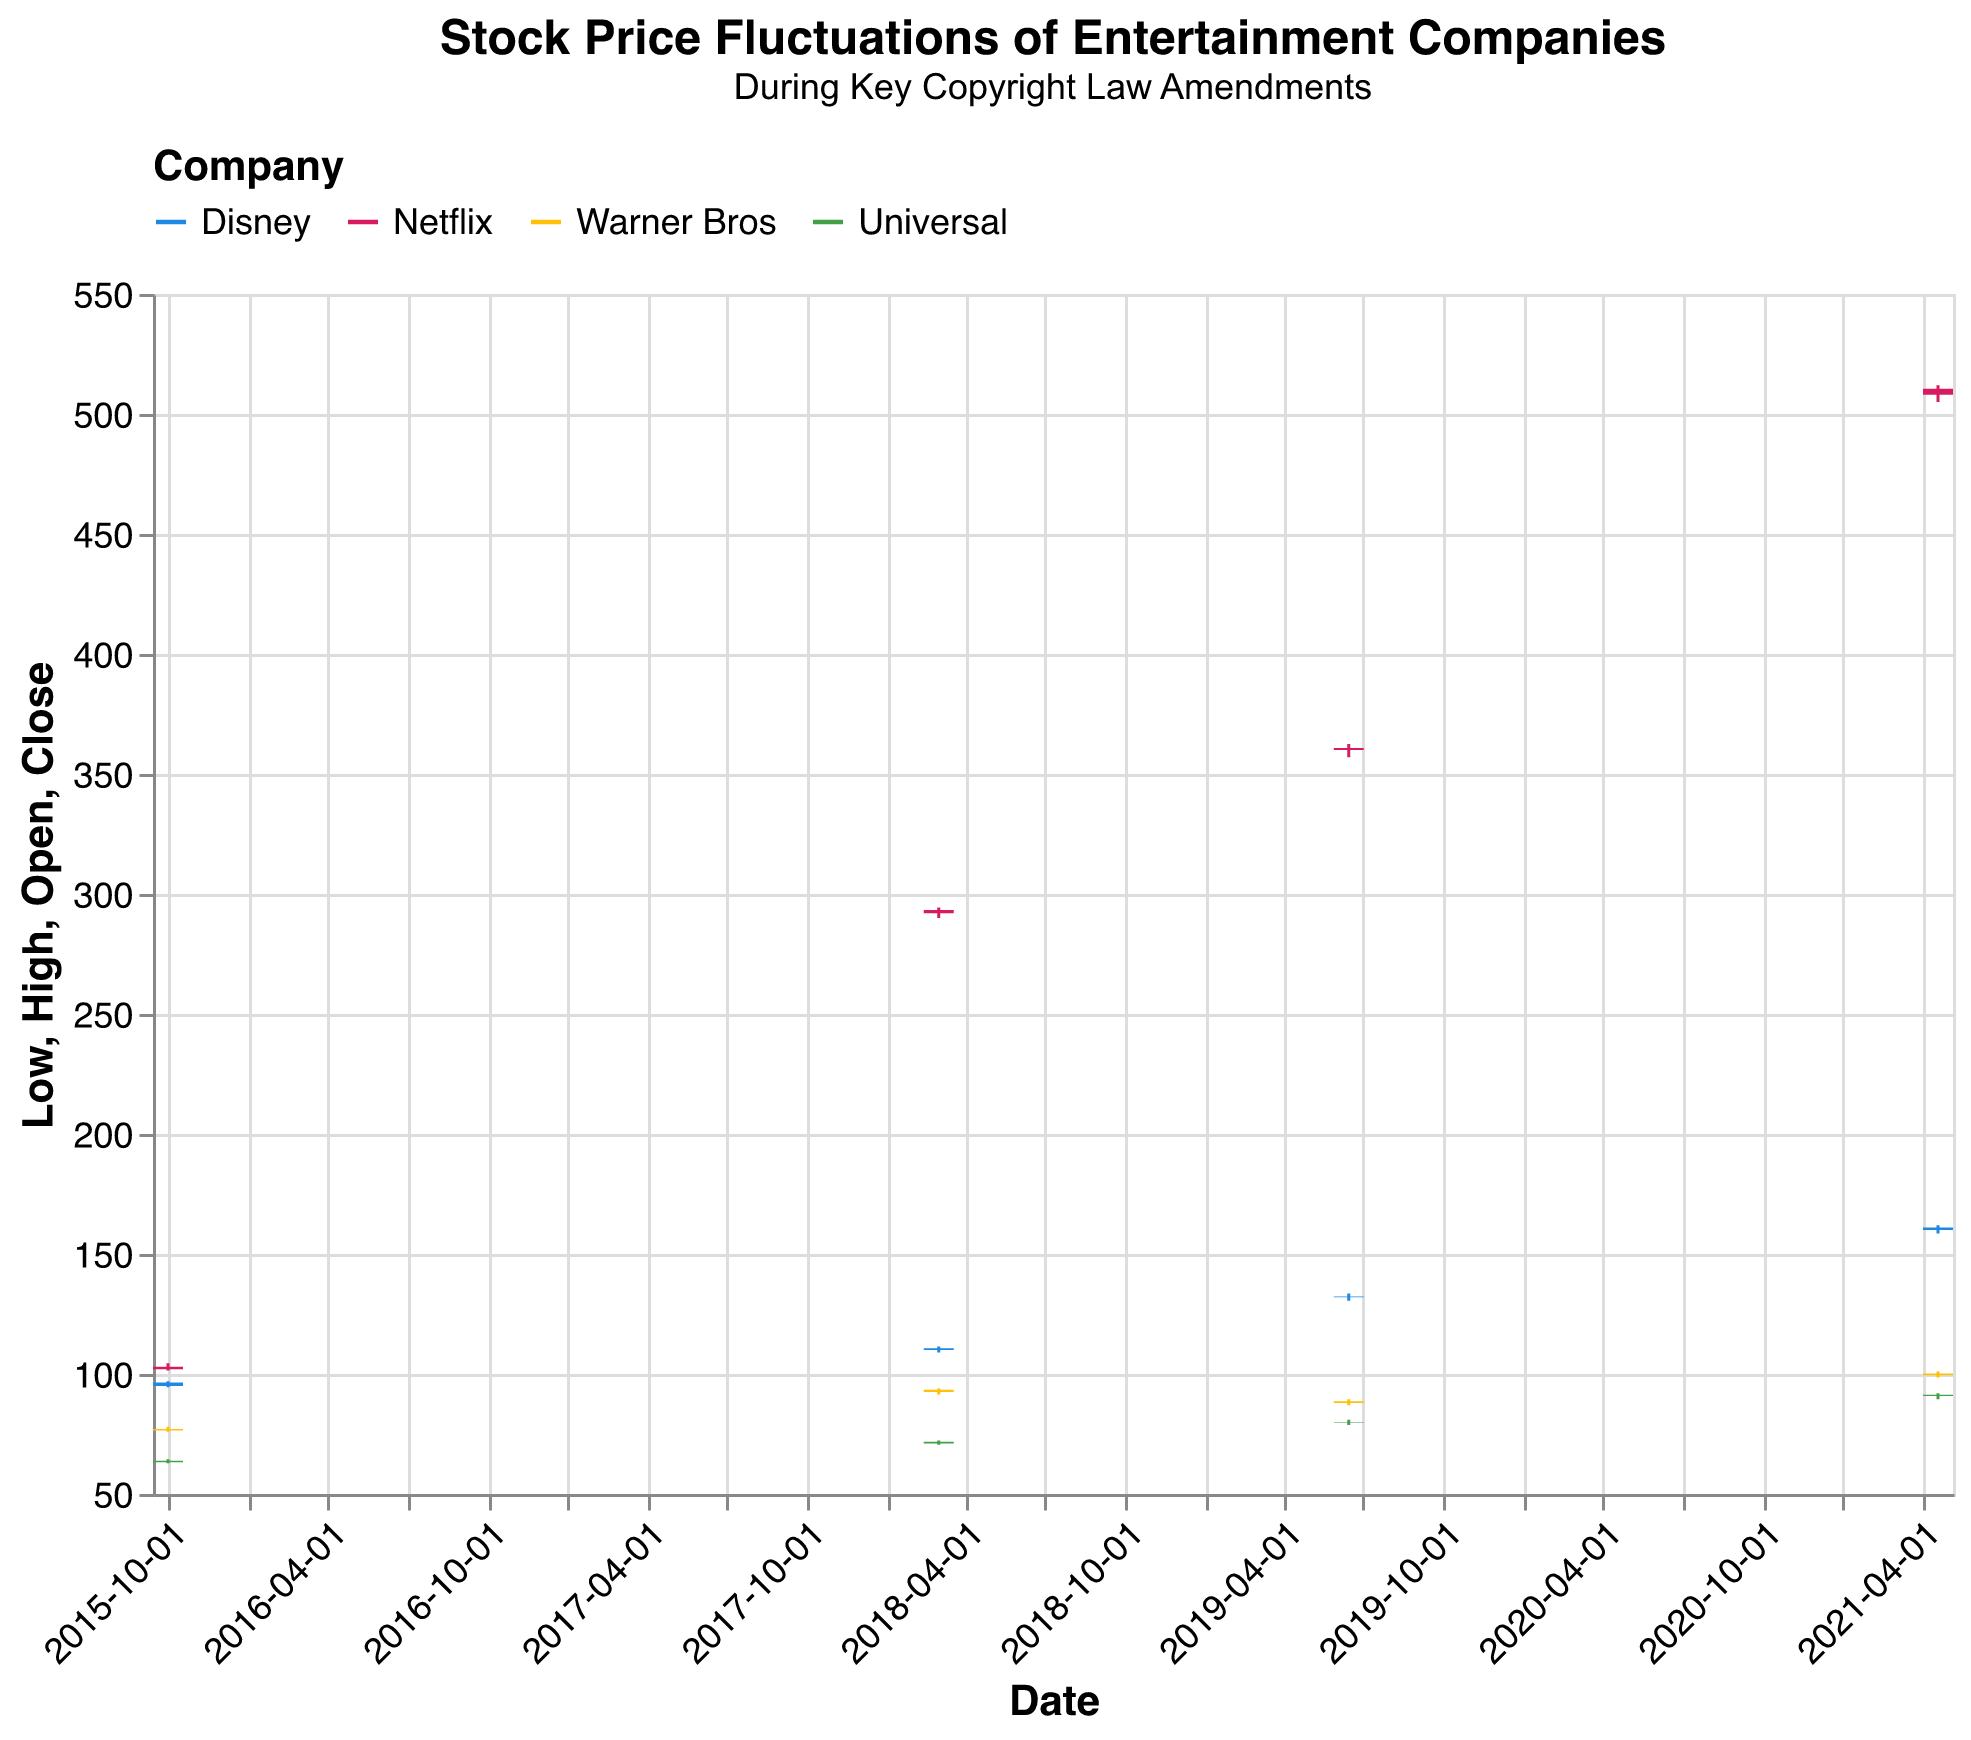What is the range of Disney's stock price on 2021-04-20? To find the range, look at the lowest (Low) and highest (High) stock prices for Disney on 2021-04-20. The Low is 158.50, and the High is 162.00, so the range is 162.00 - 158.50 = 3.50.
Answer: 3.50 Which company had the highest closing price on 2018-03-02? Check the closing prices for all companies on 2018-03-02. Disney closed at 110.70, Netflix at 293.30, Warner Bros at 93.40, and Universal at 71.80. Netflix has the highest closing price.
Answer: Netflix What is the average closing price of Disney's stock across the given dates? To find the average, sum the closing prices of Disney's stock on all given dates and divide by the number of dates. The closing prices are 96.50, 110.70, 132.30, and 161.00. Summing these gives 500.50, and dividing by 4 gives 125.125.
Answer: 125.125 How much did Netflix's stock price increase from 2015-10-01 to 2021-04-20 based on their closing prices? Find the closing prices on the two dates: 103.00 on 2015-10-01 and 510.50 on 2021-04-20. The increase is 510.50 - 103.00 = 407.50.
Answer: 407.50 Compare the trading volumes of Warner Bros and Universal's stock on 2019-06-15. Which company had a higher volume, and by how much? Check the trading volumes on 2019-06-15: Warner Bros had 8,900,000, and Universal had 9,800,000. Universal's volume was higher by 9,800,000 - 8,900,000 = 900,000.
Answer: Universal, 900,000 What was the lowest price of Netflix's stock on 2019-06-15? Look at the Low price for Netflix on 2019-06-15, which is 357.00.
Answer: 357.00 How did Universal's stock price change from the opening to the closing on 2018-03-02? Check Universal's Open and Close prices on 2018-03-02: it opened at 71.00 and closed at 71.80. The change is 71.80 - 71.00 = 0.80.
Answer: 0.80 Which company had the highest High price on 2021-04-20? Compare the High prices of all companies on 2021-04-20: Disney (162.00), Netflix (512.00), Warner Bros (101.00), Universal (92.00). Netflix has the highest High price.
Answer: Netflix What is the combined trading volume of all companies on 2015-10-01? Sum the trading volumes for all companies on 2015-10-01: Disney (12,000,000), Netflix (8,500,000), Warner Bros (9,500,000), and Universal (6,500,000). The total is 12,000,000 + 8,500,000 + 9,500,000 + 6,500,000 = 36,500,000.
Answer: 36,500,000 